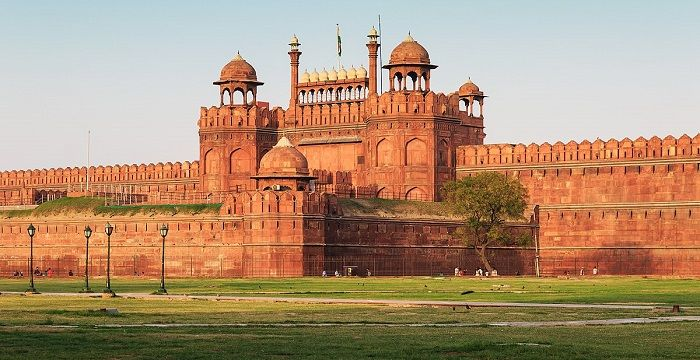What is the historical significance of the location shown in the image? This image showcases the Red Fort in Delhi, India, which is not only an architectural marvel but also a symbol of India's struggle for independence. It was from here that the Prime Minister of India, Jawaharlal Nehru, delivered the nation's first Independence Day speech at the stroke of midnight on August 15, 1947. This tradition continues today and underscores the fort's role as a political and cultural landmark. 